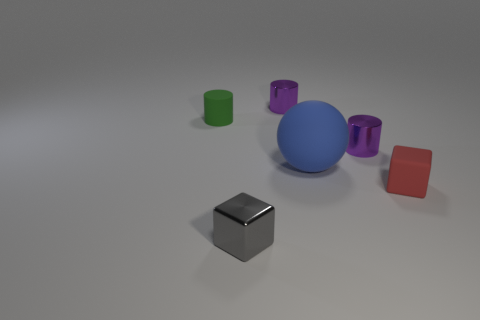Is the small matte cylinder the same color as the ball?
Ensure brevity in your answer.  No. How many things are cubes that are on the left side of the small red rubber thing or large blue objects?
Give a very brief answer. 2. The green cylinder that is made of the same material as the blue object is what size?
Make the answer very short. Small. Is the number of tiny cylinders that are right of the matte block greater than the number of red shiny spheres?
Your response must be concise. No. There is a big blue thing; is its shape the same as the matte object left of the metal cube?
Provide a succinct answer. No. How many large things are either rubber objects or green rubber cylinders?
Your response must be concise. 1. There is a small shiny object that is behind the tiny purple shiny thing in front of the green matte thing; what is its color?
Your response must be concise. Purple. Does the small gray thing have the same material as the small block to the right of the big rubber thing?
Make the answer very short. No. There is a tiny cube on the right side of the ball; what is its material?
Provide a short and direct response. Rubber. Are there an equal number of blue matte balls left of the gray metallic block and small matte blocks?
Your response must be concise. No. 